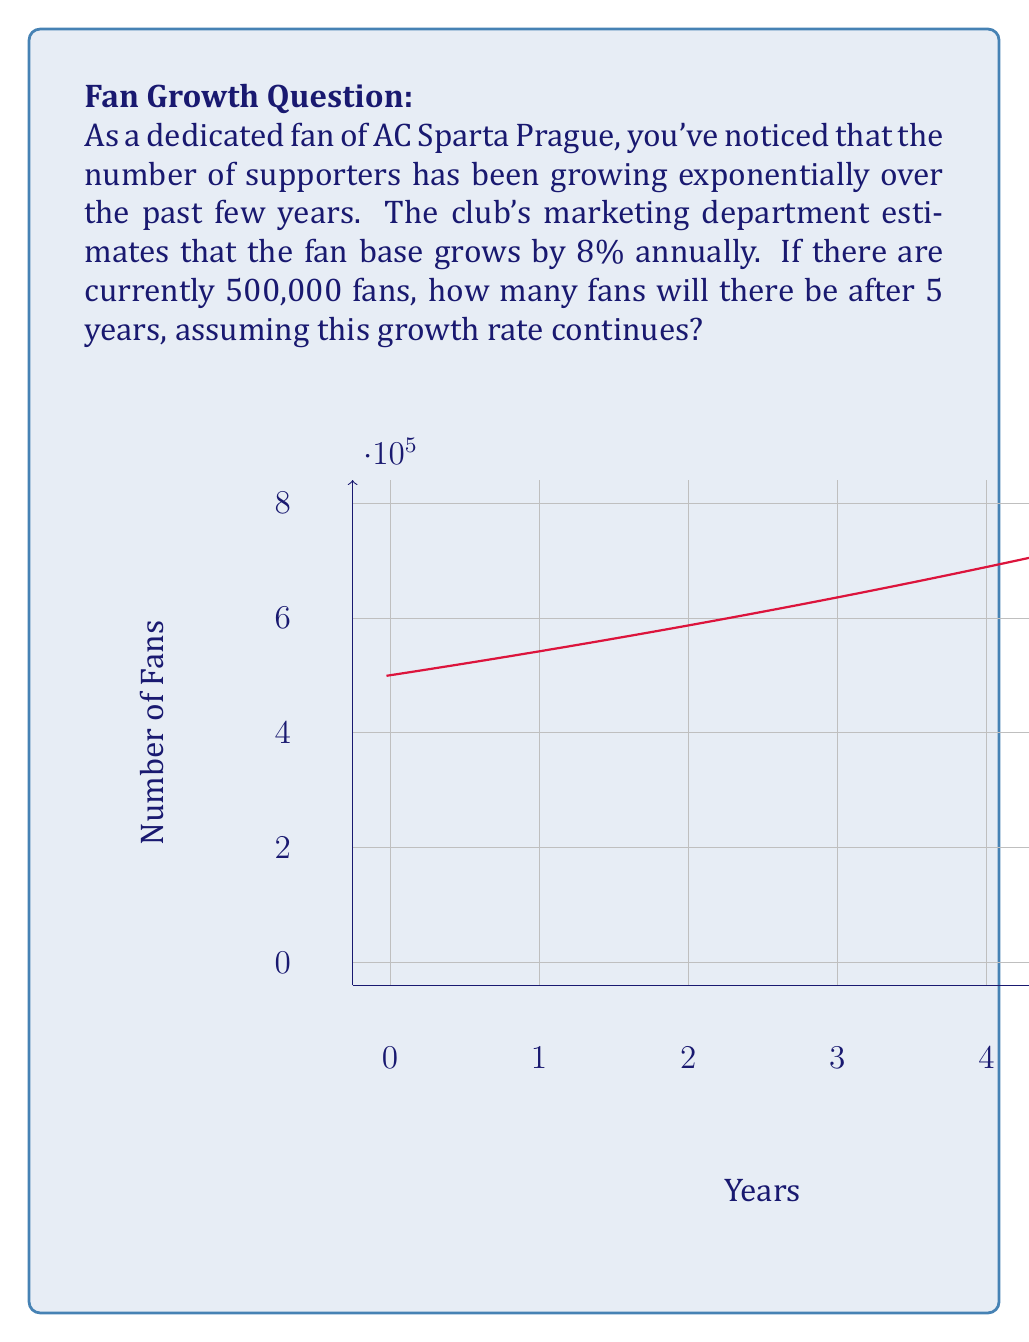Could you help me with this problem? To solve this problem, we'll use the exponential growth model:

$$P(t) = P_0 \cdot (1 + r)^t$$

Where:
$P(t)$ is the population at time $t$
$P_0$ is the initial population
$r$ is the growth rate
$t$ is the time in years

Given:
$P_0 = 500,000$ (initial number of fans)
$r = 0.08$ (8% annual growth rate)
$t = 5$ years

Let's substitute these values into the equation:

$$P(5) = 500,000 \cdot (1 + 0.08)^5$$

Now, let's calculate step-by-step:

1) First, calculate $(1 + 0.08)^5$:
   $$(1.08)^5 = 1.46933...$$

2) Multiply this by the initial population:
   $$500,000 \cdot 1.46933... = 734,663.52...$$

3) Round to the nearest whole number, as we can't have a fractional number of fans.

Therefore, after 5 years, there will be approximately 734,664 AC Sparta Prague fans.
Answer: 734,664 fans 